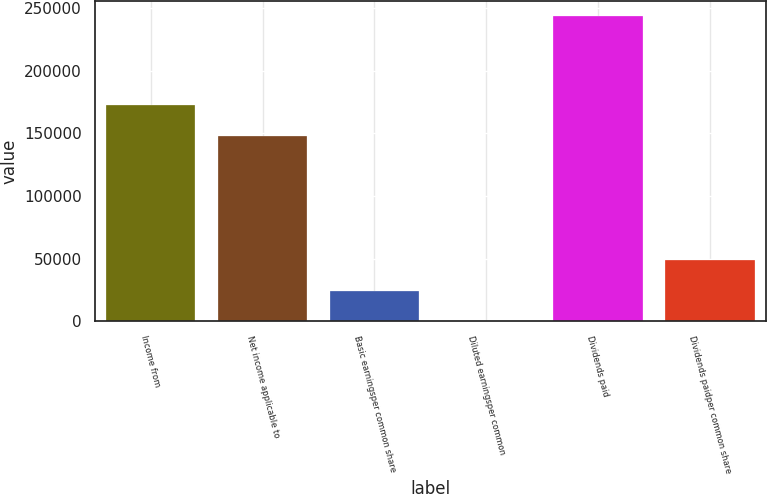Convert chart. <chart><loc_0><loc_0><loc_500><loc_500><bar_chart><fcel>Income from<fcel>Net income applicable to<fcel>Basic earningsper common share<fcel>Diluted earningsper common<fcel>Dividends paid<fcel>Dividends paidper common share<nl><fcel>172235<fcel>147910<fcel>24325.9<fcel>1<fcel>243250<fcel>48650.8<nl></chart> 